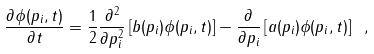<formula> <loc_0><loc_0><loc_500><loc_500>\frac { \partial \phi ( p _ { i } , t ) } { \partial t } = \frac { 1 } { 2 } \frac { \partial ^ { 2 } } { \partial p _ { i } ^ { 2 } } \left [ b ( p _ { i } ) \phi ( p _ { i } , t ) \right ] - \frac { \partial } { \partial p _ { i } } \left [ a ( p _ { i } ) \phi ( p _ { i } , t ) \right ] \ ,</formula> 